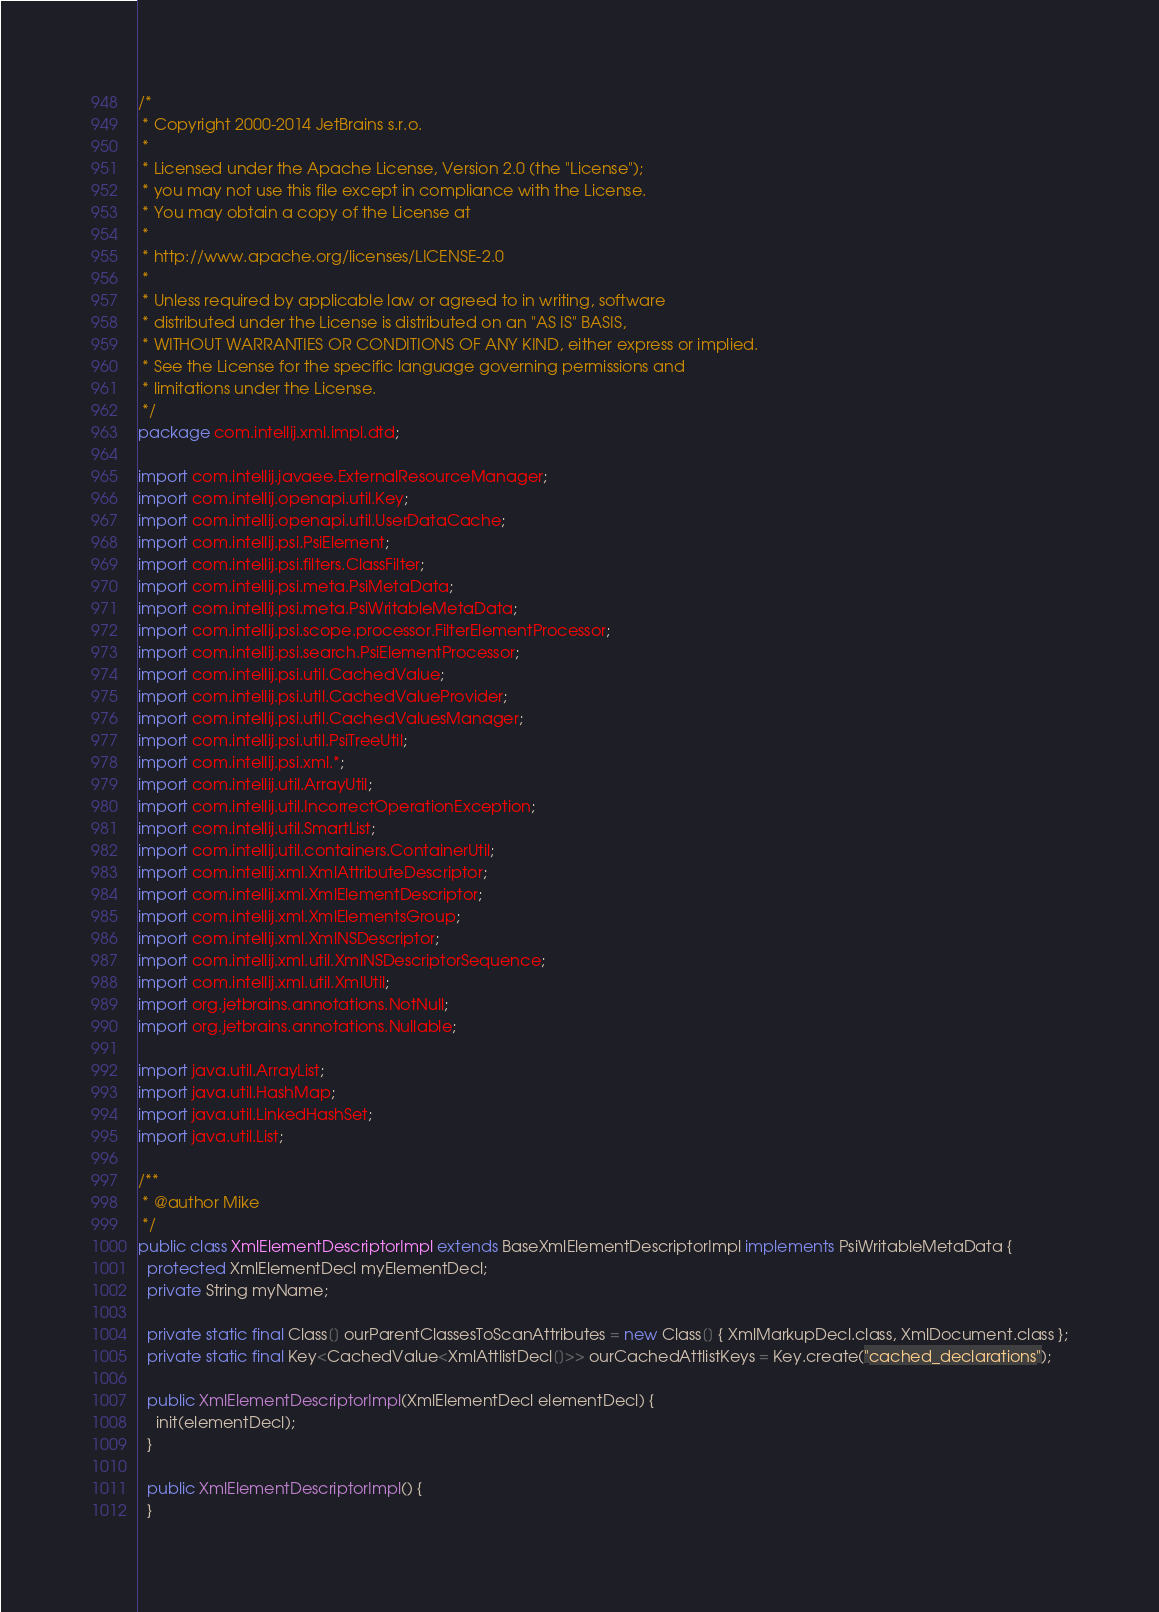<code> <loc_0><loc_0><loc_500><loc_500><_Java_>/*
 * Copyright 2000-2014 JetBrains s.r.o.
 *
 * Licensed under the Apache License, Version 2.0 (the "License");
 * you may not use this file except in compliance with the License.
 * You may obtain a copy of the License at
 *
 * http://www.apache.org/licenses/LICENSE-2.0
 *
 * Unless required by applicable law or agreed to in writing, software
 * distributed under the License is distributed on an "AS IS" BASIS,
 * WITHOUT WARRANTIES OR CONDITIONS OF ANY KIND, either express or implied.
 * See the License for the specific language governing permissions and
 * limitations under the License.
 */
package com.intellij.xml.impl.dtd;

import com.intellij.javaee.ExternalResourceManager;
import com.intellij.openapi.util.Key;
import com.intellij.openapi.util.UserDataCache;
import com.intellij.psi.PsiElement;
import com.intellij.psi.filters.ClassFilter;
import com.intellij.psi.meta.PsiMetaData;
import com.intellij.psi.meta.PsiWritableMetaData;
import com.intellij.psi.scope.processor.FilterElementProcessor;
import com.intellij.psi.search.PsiElementProcessor;
import com.intellij.psi.util.CachedValue;
import com.intellij.psi.util.CachedValueProvider;
import com.intellij.psi.util.CachedValuesManager;
import com.intellij.psi.util.PsiTreeUtil;
import com.intellij.psi.xml.*;
import com.intellij.util.ArrayUtil;
import com.intellij.util.IncorrectOperationException;
import com.intellij.util.SmartList;
import com.intellij.util.containers.ContainerUtil;
import com.intellij.xml.XmlAttributeDescriptor;
import com.intellij.xml.XmlElementDescriptor;
import com.intellij.xml.XmlElementsGroup;
import com.intellij.xml.XmlNSDescriptor;
import com.intellij.xml.util.XmlNSDescriptorSequence;
import com.intellij.xml.util.XmlUtil;
import org.jetbrains.annotations.NotNull;
import org.jetbrains.annotations.Nullable;

import java.util.ArrayList;
import java.util.HashMap;
import java.util.LinkedHashSet;
import java.util.List;

/**
 * @author Mike
 */
public class XmlElementDescriptorImpl extends BaseXmlElementDescriptorImpl implements PsiWritableMetaData {
  protected XmlElementDecl myElementDecl;
  private String myName;

  private static final Class[] ourParentClassesToScanAttributes = new Class[] { XmlMarkupDecl.class, XmlDocument.class };
  private static final Key<CachedValue<XmlAttlistDecl[]>> ourCachedAttlistKeys = Key.create("cached_declarations");

  public XmlElementDescriptorImpl(XmlElementDecl elementDecl) {
    init(elementDecl);
  }

  public XmlElementDescriptorImpl() {
  }
</code> 